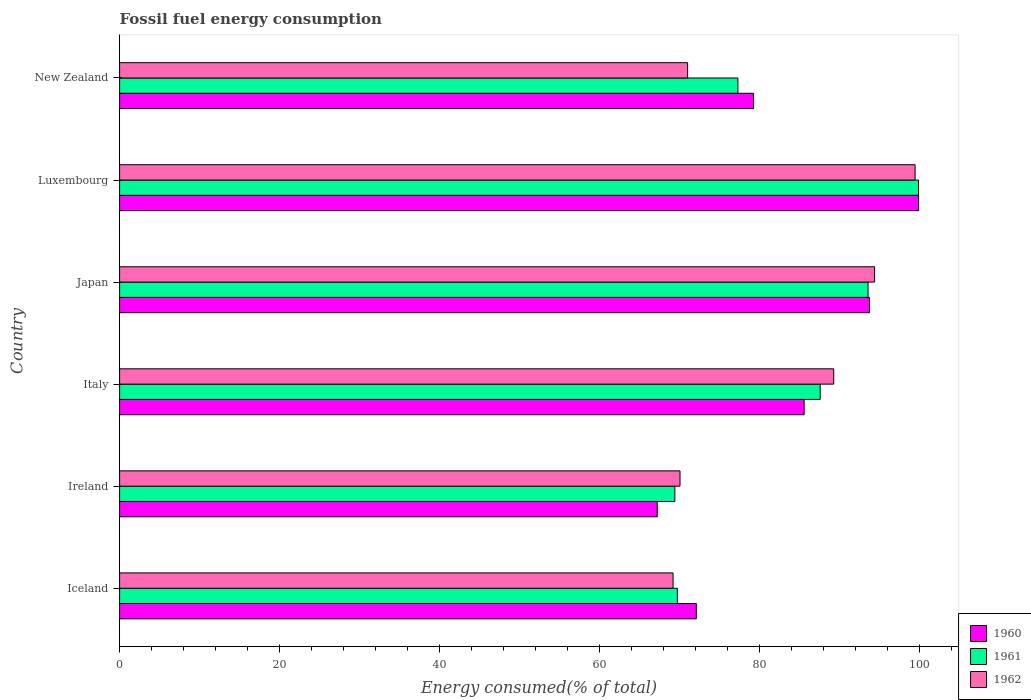How many groups of bars are there?
Offer a very short reply. 6. Are the number of bars per tick equal to the number of legend labels?
Give a very brief answer. Yes. How many bars are there on the 1st tick from the bottom?
Keep it short and to the point. 3. What is the label of the 1st group of bars from the top?
Keep it short and to the point. New Zealand. In how many cases, is the number of bars for a given country not equal to the number of legend labels?
Offer a terse response. 0. What is the percentage of energy consumed in 1962 in Iceland?
Offer a very short reply. 69.22. Across all countries, what is the maximum percentage of energy consumed in 1960?
Your response must be concise. 99.92. Across all countries, what is the minimum percentage of energy consumed in 1961?
Offer a very short reply. 69.44. In which country was the percentage of energy consumed in 1962 maximum?
Make the answer very short. Luxembourg. What is the total percentage of energy consumed in 1960 in the graph?
Make the answer very short. 497.96. What is the difference between the percentage of energy consumed in 1962 in Iceland and that in Luxembourg?
Make the answer very short. -30.27. What is the difference between the percentage of energy consumed in 1960 in New Zealand and the percentage of energy consumed in 1962 in Iceland?
Ensure brevity in your answer.  10.06. What is the average percentage of energy consumed in 1961 per country?
Your response must be concise. 82.94. What is the difference between the percentage of energy consumed in 1962 and percentage of energy consumed in 1961 in Iceland?
Your answer should be compact. -0.54. In how many countries, is the percentage of energy consumed in 1962 greater than 60 %?
Your answer should be compact. 6. What is the ratio of the percentage of energy consumed in 1962 in Japan to that in Luxembourg?
Offer a terse response. 0.95. Is the difference between the percentage of energy consumed in 1962 in Iceland and Luxembourg greater than the difference between the percentage of energy consumed in 1961 in Iceland and Luxembourg?
Your answer should be very brief. No. What is the difference between the highest and the second highest percentage of energy consumed in 1960?
Ensure brevity in your answer.  6.15. What is the difference between the highest and the lowest percentage of energy consumed in 1962?
Your answer should be very brief. 30.27. In how many countries, is the percentage of energy consumed in 1960 greater than the average percentage of energy consumed in 1960 taken over all countries?
Your response must be concise. 3. Is the sum of the percentage of energy consumed in 1960 in Iceland and New Zealand greater than the maximum percentage of energy consumed in 1962 across all countries?
Offer a very short reply. Yes. What is the difference between two consecutive major ticks on the X-axis?
Provide a short and direct response. 20. What is the title of the graph?
Your answer should be compact. Fossil fuel energy consumption. What is the label or title of the X-axis?
Your response must be concise. Energy consumed(% of total). What is the Energy consumed(% of total) of 1960 in Iceland?
Your response must be concise. 72.13. What is the Energy consumed(% of total) in 1961 in Iceland?
Your answer should be compact. 69.76. What is the Energy consumed(% of total) in 1962 in Iceland?
Make the answer very short. 69.22. What is the Energy consumed(% of total) of 1960 in Ireland?
Offer a very short reply. 67.24. What is the Energy consumed(% of total) in 1961 in Ireland?
Make the answer very short. 69.44. What is the Energy consumed(% of total) in 1962 in Ireland?
Provide a short and direct response. 70.09. What is the Energy consumed(% of total) of 1960 in Italy?
Offer a terse response. 85.61. What is the Energy consumed(% of total) of 1961 in Italy?
Provide a short and direct response. 87.62. What is the Energy consumed(% of total) in 1962 in Italy?
Provide a succinct answer. 89.31. What is the Energy consumed(% of total) in 1960 in Japan?
Make the answer very short. 93.78. What is the Energy consumed(% of total) in 1961 in Japan?
Give a very brief answer. 93.6. What is the Energy consumed(% of total) of 1962 in Japan?
Offer a very short reply. 94.42. What is the Energy consumed(% of total) in 1960 in Luxembourg?
Your answer should be very brief. 99.92. What is the Energy consumed(% of total) of 1961 in Luxembourg?
Your answer should be compact. 99.91. What is the Energy consumed(% of total) in 1962 in Luxembourg?
Ensure brevity in your answer.  99.49. What is the Energy consumed(% of total) of 1960 in New Zealand?
Make the answer very short. 79.28. What is the Energy consumed(% of total) in 1961 in New Zealand?
Provide a short and direct response. 77.33. What is the Energy consumed(% of total) in 1962 in New Zealand?
Ensure brevity in your answer.  71.04. Across all countries, what is the maximum Energy consumed(% of total) in 1960?
Offer a very short reply. 99.92. Across all countries, what is the maximum Energy consumed(% of total) in 1961?
Your answer should be compact. 99.91. Across all countries, what is the maximum Energy consumed(% of total) of 1962?
Make the answer very short. 99.49. Across all countries, what is the minimum Energy consumed(% of total) of 1960?
Provide a succinct answer. 67.24. Across all countries, what is the minimum Energy consumed(% of total) of 1961?
Provide a short and direct response. 69.44. Across all countries, what is the minimum Energy consumed(% of total) of 1962?
Offer a terse response. 69.22. What is the total Energy consumed(% of total) of 1960 in the graph?
Offer a terse response. 497.96. What is the total Energy consumed(% of total) of 1961 in the graph?
Provide a short and direct response. 497.66. What is the total Energy consumed(% of total) in 1962 in the graph?
Your answer should be compact. 493.56. What is the difference between the Energy consumed(% of total) of 1960 in Iceland and that in Ireland?
Offer a very short reply. 4.89. What is the difference between the Energy consumed(% of total) of 1961 in Iceland and that in Ireland?
Provide a succinct answer. 0.32. What is the difference between the Energy consumed(% of total) in 1962 in Iceland and that in Ireland?
Keep it short and to the point. -0.87. What is the difference between the Energy consumed(% of total) in 1960 in Iceland and that in Italy?
Offer a terse response. -13.48. What is the difference between the Energy consumed(% of total) in 1961 in Iceland and that in Italy?
Your answer should be compact. -17.86. What is the difference between the Energy consumed(% of total) in 1962 in Iceland and that in Italy?
Ensure brevity in your answer.  -20.09. What is the difference between the Energy consumed(% of total) of 1960 in Iceland and that in Japan?
Offer a terse response. -21.65. What is the difference between the Energy consumed(% of total) of 1961 in Iceland and that in Japan?
Provide a succinct answer. -23.85. What is the difference between the Energy consumed(% of total) of 1962 in Iceland and that in Japan?
Provide a short and direct response. -25.2. What is the difference between the Energy consumed(% of total) in 1960 in Iceland and that in Luxembourg?
Your answer should be compact. -27.8. What is the difference between the Energy consumed(% of total) in 1961 in Iceland and that in Luxembourg?
Your response must be concise. -30.16. What is the difference between the Energy consumed(% of total) of 1962 in Iceland and that in Luxembourg?
Offer a very short reply. -30.27. What is the difference between the Energy consumed(% of total) in 1960 in Iceland and that in New Zealand?
Ensure brevity in your answer.  -7.15. What is the difference between the Energy consumed(% of total) of 1961 in Iceland and that in New Zealand?
Provide a short and direct response. -7.57. What is the difference between the Energy consumed(% of total) of 1962 in Iceland and that in New Zealand?
Keep it short and to the point. -1.82. What is the difference between the Energy consumed(% of total) in 1960 in Ireland and that in Italy?
Your answer should be compact. -18.37. What is the difference between the Energy consumed(% of total) in 1961 in Ireland and that in Italy?
Your answer should be compact. -18.18. What is the difference between the Energy consumed(% of total) of 1962 in Ireland and that in Italy?
Offer a very short reply. -19.23. What is the difference between the Energy consumed(% of total) of 1960 in Ireland and that in Japan?
Your response must be concise. -26.53. What is the difference between the Energy consumed(% of total) in 1961 in Ireland and that in Japan?
Your response must be concise. -24.16. What is the difference between the Energy consumed(% of total) in 1962 in Ireland and that in Japan?
Give a very brief answer. -24.34. What is the difference between the Energy consumed(% of total) in 1960 in Ireland and that in Luxembourg?
Your response must be concise. -32.68. What is the difference between the Energy consumed(% of total) in 1961 in Ireland and that in Luxembourg?
Offer a terse response. -30.47. What is the difference between the Energy consumed(% of total) in 1962 in Ireland and that in Luxembourg?
Ensure brevity in your answer.  -29.4. What is the difference between the Energy consumed(% of total) in 1960 in Ireland and that in New Zealand?
Keep it short and to the point. -12.04. What is the difference between the Energy consumed(% of total) of 1961 in Ireland and that in New Zealand?
Give a very brief answer. -7.89. What is the difference between the Energy consumed(% of total) of 1962 in Ireland and that in New Zealand?
Offer a terse response. -0.95. What is the difference between the Energy consumed(% of total) of 1960 in Italy and that in Japan?
Your answer should be compact. -8.17. What is the difference between the Energy consumed(% of total) in 1961 in Italy and that in Japan?
Keep it short and to the point. -5.99. What is the difference between the Energy consumed(% of total) in 1962 in Italy and that in Japan?
Make the answer very short. -5.11. What is the difference between the Energy consumed(% of total) in 1960 in Italy and that in Luxembourg?
Give a very brief answer. -14.31. What is the difference between the Energy consumed(% of total) in 1961 in Italy and that in Luxembourg?
Offer a terse response. -12.3. What is the difference between the Energy consumed(% of total) of 1962 in Italy and that in Luxembourg?
Provide a short and direct response. -10.18. What is the difference between the Energy consumed(% of total) in 1960 in Italy and that in New Zealand?
Provide a succinct answer. 6.33. What is the difference between the Energy consumed(% of total) in 1961 in Italy and that in New Zealand?
Your response must be concise. 10.29. What is the difference between the Energy consumed(% of total) in 1962 in Italy and that in New Zealand?
Provide a succinct answer. 18.27. What is the difference between the Energy consumed(% of total) in 1960 in Japan and that in Luxembourg?
Your answer should be compact. -6.15. What is the difference between the Energy consumed(% of total) in 1961 in Japan and that in Luxembourg?
Offer a very short reply. -6.31. What is the difference between the Energy consumed(% of total) of 1962 in Japan and that in Luxembourg?
Offer a very short reply. -5.07. What is the difference between the Energy consumed(% of total) in 1960 in Japan and that in New Zealand?
Make the answer very short. 14.5. What is the difference between the Energy consumed(% of total) in 1961 in Japan and that in New Zealand?
Provide a short and direct response. 16.28. What is the difference between the Energy consumed(% of total) of 1962 in Japan and that in New Zealand?
Make the answer very short. 23.38. What is the difference between the Energy consumed(% of total) in 1960 in Luxembourg and that in New Zealand?
Provide a short and direct response. 20.65. What is the difference between the Energy consumed(% of total) in 1961 in Luxembourg and that in New Zealand?
Offer a very short reply. 22.58. What is the difference between the Energy consumed(% of total) of 1962 in Luxembourg and that in New Zealand?
Give a very brief answer. 28.45. What is the difference between the Energy consumed(% of total) in 1960 in Iceland and the Energy consumed(% of total) in 1961 in Ireland?
Give a very brief answer. 2.69. What is the difference between the Energy consumed(% of total) of 1960 in Iceland and the Energy consumed(% of total) of 1962 in Ireland?
Your answer should be very brief. 2.04. What is the difference between the Energy consumed(% of total) of 1961 in Iceland and the Energy consumed(% of total) of 1962 in Ireland?
Offer a terse response. -0.33. What is the difference between the Energy consumed(% of total) in 1960 in Iceland and the Energy consumed(% of total) in 1961 in Italy?
Provide a short and direct response. -15.49. What is the difference between the Energy consumed(% of total) in 1960 in Iceland and the Energy consumed(% of total) in 1962 in Italy?
Your response must be concise. -17.18. What is the difference between the Energy consumed(% of total) of 1961 in Iceland and the Energy consumed(% of total) of 1962 in Italy?
Make the answer very short. -19.55. What is the difference between the Energy consumed(% of total) of 1960 in Iceland and the Energy consumed(% of total) of 1961 in Japan?
Keep it short and to the point. -21.48. What is the difference between the Energy consumed(% of total) of 1960 in Iceland and the Energy consumed(% of total) of 1962 in Japan?
Offer a very short reply. -22.29. What is the difference between the Energy consumed(% of total) of 1961 in Iceland and the Energy consumed(% of total) of 1962 in Japan?
Your answer should be very brief. -24.66. What is the difference between the Energy consumed(% of total) of 1960 in Iceland and the Energy consumed(% of total) of 1961 in Luxembourg?
Offer a terse response. -27.78. What is the difference between the Energy consumed(% of total) of 1960 in Iceland and the Energy consumed(% of total) of 1962 in Luxembourg?
Keep it short and to the point. -27.36. What is the difference between the Energy consumed(% of total) of 1961 in Iceland and the Energy consumed(% of total) of 1962 in Luxembourg?
Offer a terse response. -29.73. What is the difference between the Energy consumed(% of total) of 1960 in Iceland and the Energy consumed(% of total) of 1961 in New Zealand?
Provide a short and direct response. -5.2. What is the difference between the Energy consumed(% of total) of 1960 in Iceland and the Energy consumed(% of total) of 1962 in New Zealand?
Give a very brief answer. 1.09. What is the difference between the Energy consumed(% of total) in 1961 in Iceland and the Energy consumed(% of total) in 1962 in New Zealand?
Provide a short and direct response. -1.28. What is the difference between the Energy consumed(% of total) in 1960 in Ireland and the Energy consumed(% of total) in 1961 in Italy?
Offer a terse response. -20.38. What is the difference between the Energy consumed(% of total) of 1960 in Ireland and the Energy consumed(% of total) of 1962 in Italy?
Provide a succinct answer. -22.07. What is the difference between the Energy consumed(% of total) in 1961 in Ireland and the Energy consumed(% of total) in 1962 in Italy?
Offer a terse response. -19.87. What is the difference between the Energy consumed(% of total) of 1960 in Ireland and the Energy consumed(% of total) of 1961 in Japan?
Keep it short and to the point. -26.36. What is the difference between the Energy consumed(% of total) in 1960 in Ireland and the Energy consumed(% of total) in 1962 in Japan?
Provide a succinct answer. -27.18. What is the difference between the Energy consumed(% of total) of 1961 in Ireland and the Energy consumed(% of total) of 1962 in Japan?
Provide a short and direct response. -24.98. What is the difference between the Energy consumed(% of total) of 1960 in Ireland and the Energy consumed(% of total) of 1961 in Luxembourg?
Your answer should be very brief. -32.67. What is the difference between the Energy consumed(% of total) of 1960 in Ireland and the Energy consumed(% of total) of 1962 in Luxembourg?
Make the answer very short. -32.25. What is the difference between the Energy consumed(% of total) in 1961 in Ireland and the Energy consumed(% of total) in 1962 in Luxembourg?
Keep it short and to the point. -30.05. What is the difference between the Energy consumed(% of total) of 1960 in Ireland and the Energy consumed(% of total) of 1961 in New Zealand?
Keep it short and to the point. -10.09. What is the difference between the Energy consumed(% of total) of 1960 in Ireland and the Energy consumed(% of total) of 1962 in New Zealand?
Your answer should be compact. -3.79. What is the difference between the Energy consumed(% of total) in 1961 in Ireland and the Energy consumed(% of total) in 1962 in New Zealand?
Your response must be concise. -1.6. What is the difference between the Energy consumed(% of total) in 1960 in Italy and the Energy consumed(% of total) in 1961 in Japan?
Keep it short and to the point. -7.99. What is the difference between the Energy consumed(% of total) of 1960 in Italy and the Energy consumed(% of total) of 1962 in Japan?
Provide a succinct answer. -8.81. What is the difference between the Energy consumed(% of total) of 1961 in Italy and the Energy consumed(% of total) of 1962 in Japan?
Give a very brief answer. -6.8. What is the difference between the Energy consumed(% of total) of 1960 in Italy and the Energy consumed(% of total) of 1961 in Luxembourg?
Make the answer very short. -14.3. What is the difference between the Energy consumed(% of total) in 1960 in Italy and the Energy consumed(% of total) in 1962 in Luxembourg?
Your answer should be compact. -13.88. What is the difference between the Energy consumed(% of total) in 1961 in Italy and the Energy consumed(% of total) in 1962 in Luxembourg?
Make the answer very short. -11.87. What is the difference between the Energy consumed(% of total) of 1960 in Italy and the Energy consumed(% of total) of 1961 in New Zealand?
Give a very brief answer. 8.28. What is the difference between the Energy consumed(% of total) of 1960 in Italy and the Energy consumed(% of total) of 1962 in New Zealand?
Offer a terse response. 14.57. What is the difference between the Energy consumed(% of total) in 1961 in Italy and the Energy consumed(% of total) in 1962 in New Zealand?
Offer a terse response. 16.58. What is the difference between the Energy consumed(% of total) of 1960 in Japan and the Energy consumed(% of total) of 1961 in Luxembourg?
Make the answer very short. -6.14. What is the difference between the Energy consumed(% of total) in 1960 in Japan and the Energy consumed(% of total) in 1962 in Luxembourg?
Offer a very short reply. -5.71. What is the difference between the Energy consumed(% of total) in 1961 in Japan and the Energy consumed(% of total) in 1962 in Luxembourg?
Make the answer very short. -5.88. What is the difference between the Energy consumed(% of total) in 1960 in Japan and the Energy consumed(% of total) in 1961 in New Zealand?
Your response must be concise. 16.45. What is the difference between the Energy consumed(% of total) in 1960 in Japan and the Energy consumed(% of total) in 1962 in New Zealand?
Offer a terse response. 22.74. What is the difference between the Energy consumed(% of total) of 1961 in Japan and the Energy consumed(% of total) of 1962 in New Zealand?
Your response must be concise. 22.57. What is the difference between the Energy consumed(% of total) in 1960 in Luxembourg and the Energy consumed(% of total) in 1961 in New Zealand?
Offer a very short reply. 22.6. What is the difference between the Energy consumed(% of total) in 1960 in Luxembourg and the Energy consumed(% of total) in 1962 in New Zealand?
Offer a very short reply. 28.89. What is the difference between the Energy consumed(% of total) of 1961 in Luxembourg and the Energy consumed(% of total) of 1962 in New Zealand?
Provide a succinct answer. 28.88. What is the average Energy consumed(% of total) of 1960 per country?
Provide a succinct answer. 82.99. What is the average Energy consumed(% of total) of 1961 per country?
Provide a succinct answer. 82.94. What is the average Energy consumed(% of total) of 1962 per country?
Your response must be concise. 82.26. What is the difference between the Energy consumed(% of total) in 1960 and Energy consumed(% of total) in 1961 in Iceland?
Your response must be concise. 2.37. What is the difference between the Energy consumed(% of total) in 1960 and Energy consumed(% of total) in 1962 in Iceland?
Give a very brief answer. 2.91. What is the difference between the Energy consumed(% of total) of 1961 and Energy consumed(% of total) of 1962 in Iceland?
Provide a short and direct response. 0.54. What is the difference between the Energy consumed(% of total) in 1960 and Energy consumed(% of total) in 1961 in Ireland?
Your response must be concise. -2.2. What is the difference between the Energy consumed(% of total) of 1960 and Energy consumed(% of total) of 1962 in Ireland?
Make the answer very short. -2.84. What is the difference between the Energy consumed(% of total) of 1961 and Energy consumed(% of total) of 1962 in Ireland?
Provide a succinct answer. -0.65. What is the difference between the Energy consumed(% of total) in 1960 and Energy consumed(% of total) in 1961 in Italy?
Give a very brief answer. -2.01. What is the difference between the Energy consumed(% of total) of 1960 and Energy consumed(% of total) of 1962 in Italy?
Offer a very short reply. -3.7. What is the difference between the Energy consumed(% of total) of 1961 and Energy consumed(% of total) of 1962 in Italy?
Offer a terse response. -1.69. What is the difference between the Energy consumed(% of total) in 1960 and Energy consumed(% of total) in 1961 in Japan?
Your answer should be compact. 0.17. What is the difference between the Energy consumed(% of total) in 1960 and Energy consumed(% of total) in 1962 in Japan?
Your answer should be very brief. -0.64. What is the difference between the Energy consumed(% of total) of 1961 and Energy consumed(% of total) of 1962 in Japan?
Provide a succinct answer. -0.82. What is the difference between the Energy consumed(% of total) of 1960 and Energy consumed(% of total) of 1961 in Luxembourg?
Provide a succinct answer. 0.01. What is the difference between the Energy consumed(% of total) in 1960 and Energy consumed(% of total) in 1962 in Luxembourg?
Keep it short and to the point. 0.44. What is the difference between the Energy consumed(% of total) in 1961 and Energy consumed(% of total) in 1962 in Luxembourg?
Keep it short and to the point. 0.42. What is the difference between the Energy consumed(% of total) in 1960 and Energy consumed(% of total) in 1961 in New Zealand?
Provide a short and direct response. 1.95. What is the difference between the Energy consumed(% of total) of 1960 and Energy consumed(% of total) of 1962 in New Zealand?
Keep it short and to the point. 8.24. What is the difference between the Energy consumed(% of total) in 1961 and Energy consumed(% of total) in 1962 in New Zealand?
Make the answer very short. 6.29. What is the ratio of the Energy consumed(% of total) of 1960 in Iceland to that in Ireland?
Ensure brevity in your answer.  1.07. What is the ratio of the Energy consumed(% of total) of 1961 in Iceland to that in Ireland?
Provide a short and direct response. 1. What is the ratio of the Energy consumed(% of total) of 1962 in Iceland to that in Ireland?
Ensure brevity in your answer.  0.99. What is the ratio of the Energy consumed(% of total) of 1960 in Iceland to that in Italy?
Your response must be concise. 0.84. What is the ratio of the Energy consumed(% of total) of 1961 in Iceland to that in Italy?
Your response must be concise. 0.8. What is the ratio of the Energy consumed(% of total) in 1962 in Iceland to that in Italy?
Offer a terse response. 0.78. What is the ratio of the Energy consumed(% of total) in 1960 in Iceland to that in Japan?
Keep it short and to the point. 0.77. What is the ratio of the Energy consumed(% of total) of 1961 in Iceland to that in Japan?
Ensure brevity in your answer.  0.75. What is the ratio of the Energy consumed(% of total) of 1962 in Iceland to that in Japan?
Your answer should be very brief. 0.73. What is the ratio of the Energy consumed(% of total) in 1960 in Iceland to that in Luxembourg?
Your answer should be compact. 0.72. What is the ratio of the Energy consumed(% of total) of 1961 in Iceland to that in Luxembourg?
Keep it short and to the point. 0.7. What is the ratio of the Energy consumed(% of total) in 1962 in Iceland to that in Luxembourg?
Give a very brief answer. 0.7. What is the ratio of the Energy consumed(% of total) of 1960 in Iceland to that in New Zealand?
Your answer should be very brief. 0.91. What is the ratio of the Energy consumed(% of total) of 1961 in Iceland to that in New Zealand?
Your answer should be compact. 0.9. What is the ratio of the Energy consumed(% of total) in 1962 in Iceland to that in New Zealand?
Your answer should be very brief. 0.97. What is the ratio of the Energy consumed(% of total) of 1960 in Ireland to that in Italy?
Provide a short and direct response. 0.79. What is the ratio of the Energy consumed(% of total) in 1961 in Ireland to that in Italy?
Your answer should be very brief. 0.79. What is the ratio of the Energy consumed(% of total) of 1962 in Ireland to that in Italy?
Give a very brief answer. 0.78. What is the ratio of the Energy consumed(% of total) of 1960 in Ireland to that in Japan?
Your response must be concise. 0.72. What is the ratio of the Energy consumed(% of total) of 1961 in Ireland to that in Japan?
Give a very brief answer. 0.74. What is the ratio of the Energy consumed(% of total) of 1962 in Ireland to that in Japan?
Your response must be concise. 0.74. What is the ratio of the Energy consumed(% of total) in 1960 in Ireland to that in Luxembourg?
Your response must be concise. 0.67. What is the ratio of the Energy consumed(% of total) of 1961 in Ireland to that in Luxembourg?
Ensure brevity in your answer.  0.69. What is the ratio of the Energy consumed(% of total) in 1962 in Ireland to that in Luxembourg?
Ensure brevity in your answer.  0.7. What is the ratio of the Energy consumed(% of total) of 1960 in Ireland to that in New Zealand?
Offer a terse response. 0.85. What is the ratio of the Energy consumed(% of total) of 1961 in Ireland to that in New Zealand?
Provide a short and direct response. 0.9. What is the ratio of the Energy consumed(% of total) in 1962 in Ireland to that in New Zealand?
Your answer should be compact. 0.99. What is the ratio of the Energy consumed(% of total) of 1960 in Italy to that in Japan?
Keep it short and to the point. 0.91. What is the ratio of the Energy consumed(% of total) in 1961 in Italy to that in Japan?
Offer a terse response. 0.94. What is the ratio of the Energy consumed(% of total) of 1962 in Italy to that in Japan?
Offer a terse response. 0.95. What is the ratio of the Energy consumed(% of total) in 1960 in Italy to that in Luxembourg?
Ensure brevity in your answer.  0.86. What is the ratio of the Energy consumed(% of total) in 1961 in Italy to that in Luxembourg?
Keep it short and to the point. 0.88. What is the ratio of the Energy consumed(% of total) in 1962 in Italy to that in Luxembourg?
Keep it short and to the point. 0.9. What is the ratio of the Energy consumed(% of total) in 1960 in Italy to that in New Zealand?
Provide a succinct answer. 1.08. What is the ratio of the Energy consumed(% of total) in 1961 in Italy to that in New Zealand?
Your answer should be very brief. 1.13. What is the ratio of the Energy consumed(% of total) in 1962 in Italy to that in New Zealand?
Your answer should be compact. 1.26. What is the ratio of the Energy consumed(% of total) of 1960 in Japan to that in Luxembourg?
Provide a succinct answer. 0.94. What is the ratio of the Energy consumed(% of total) of 1961 in Japan to that in Luxembourg?
Provide a short and direct response. 0.94. What is the ratio of the Energy consumed(% of total) in 1962 in Japan to that in Luxembourg?
Make the answer very short. 0.95. What is the ratio of the Energy consumed(% of total) of 1960 in Japan to that in New Zealand?
Your response must be concise. 1.18. What is the ratio of the Energy consumed(% of total) in 1961 in Japan to that in New Zealand?
Your answer should be very brief. 1.21. What is the ratio of the Energy consumed(% of total) of 1962 in Japan to that in New Zealand?
Make the answer very short. 1.33. What is the ratio of the Energy consumed(% of total) of 1960 in Luxembourg to that in New Zealand?
Give a very brief answer. 1.26. What is the ratio of the Energy consumed(% of total) in 1961 in Luxembourg to that in New Zealand?
Provide a short and direct response. 1.29. What is the ratio of the Energy consumed(% of total) in 1962 in Luxembourg to that in New Zealand?
Your answer should be compact. 1.4. What is the difference between the highest and the second highest Energy consumed(% of total) in 1960?
Make the answer very short. 6.15. What is the difference between the highest and the second highest Energy consumed(% of total) of 1961?
Your answer should be compact. 6.31. What is the difference between the highest and the second highest Energy consumed(% of total) in 1962?
Offer a terse response. 5.07. What is the difference between the highest and the lowest Energy consumed(% of total) of 1960?
Provide a succinct answer. 32.68. What is the difference between the highest and the lowest Energy consumed(% of total) of 1961?
Provide a short and direct response. 30.47. What is the difference between the highest and the lowest Energy consumed(% of total) in 1962?
Ensure brevity in your answer.  30.27. 